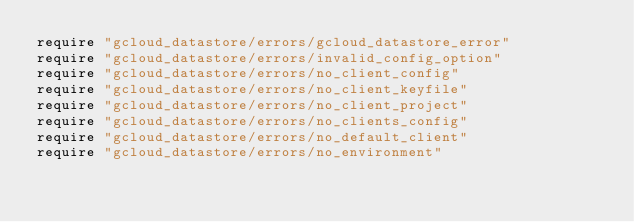<code> <loc_0><loc_0><loc_500><loc_500><_Ruby_>require "gcloud_datastore/errors/gcloud_datastore_error"
require "gcloud_datastore/errors/invalid_config_option"
require "gcloud_datastore/errors/no_client_config"
require "gcloud_datastore/errors/no_client_keyfile"
require "gcloud_datastore/errors/no_client_project"
require "gcloud_datastore/errors/no_clients_config"
require "gcloud_datastore/errors/no_default_client"
require "gcloud_datastore/errors/no_environment"
</code> 